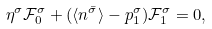Convert formula to latex. <formula><loc_0><loc_0><loc_500><loc_500>\eta ^ { \sigma } \mathcal { F } _ { 0 } ^ { \sigma } + ( \langle n ^ { \bar { \sigma } } \rangle - p _ { 1 } ^ { \sigma } ) \mathcal { F } _ { 1 } ^ { \sigma } = 0 ,</formula> 